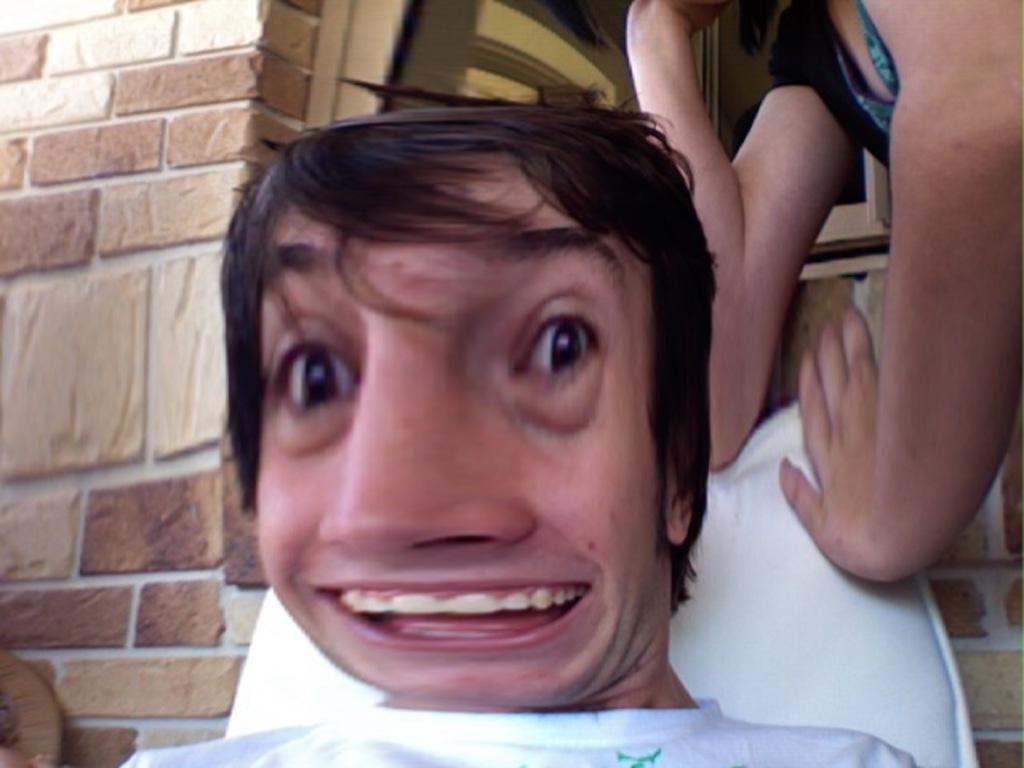What is the main subject of the image? There is an illusion of people in the image. What else can be seen in the image besides the people? There is a building in the image. Can you describe the building in more detail? The building has a window in the middle. How many knots are tied on the feet of the people in the image? There are no knots or feet visible in the image, as it features an illusion of people. 